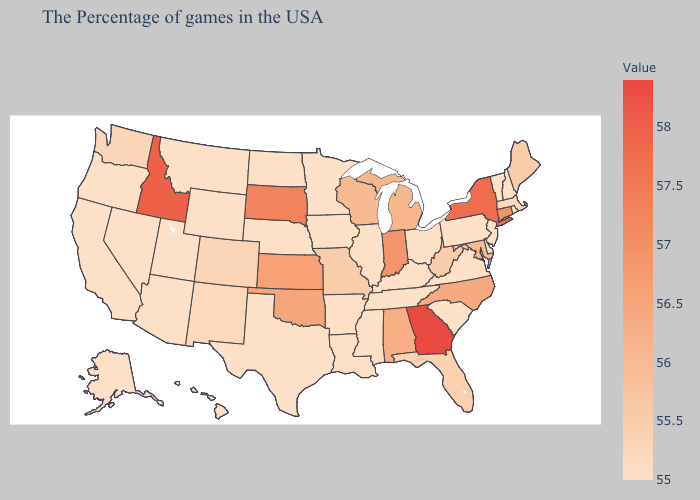Does Massachusetts have the highest value in the Northeast?
Concise answer only. No. Does New York have the highest value in the Northeast?
Quick response, please. Yes. Does Idaho have the lowest value in the West?
Answer briefly. No. Does Connecticut have the highest value in the Northeast?
Write a very short answer. No. Is the legend a continuous bar?
Be succinct. Yes. Does West Virginia have the lowest value in the South?
Answer briefly. No. Which states have the highest value in the USA?
Write a very short answer. Georgia. Is the legend a continuous bar?
Answer briefly. Yes. 